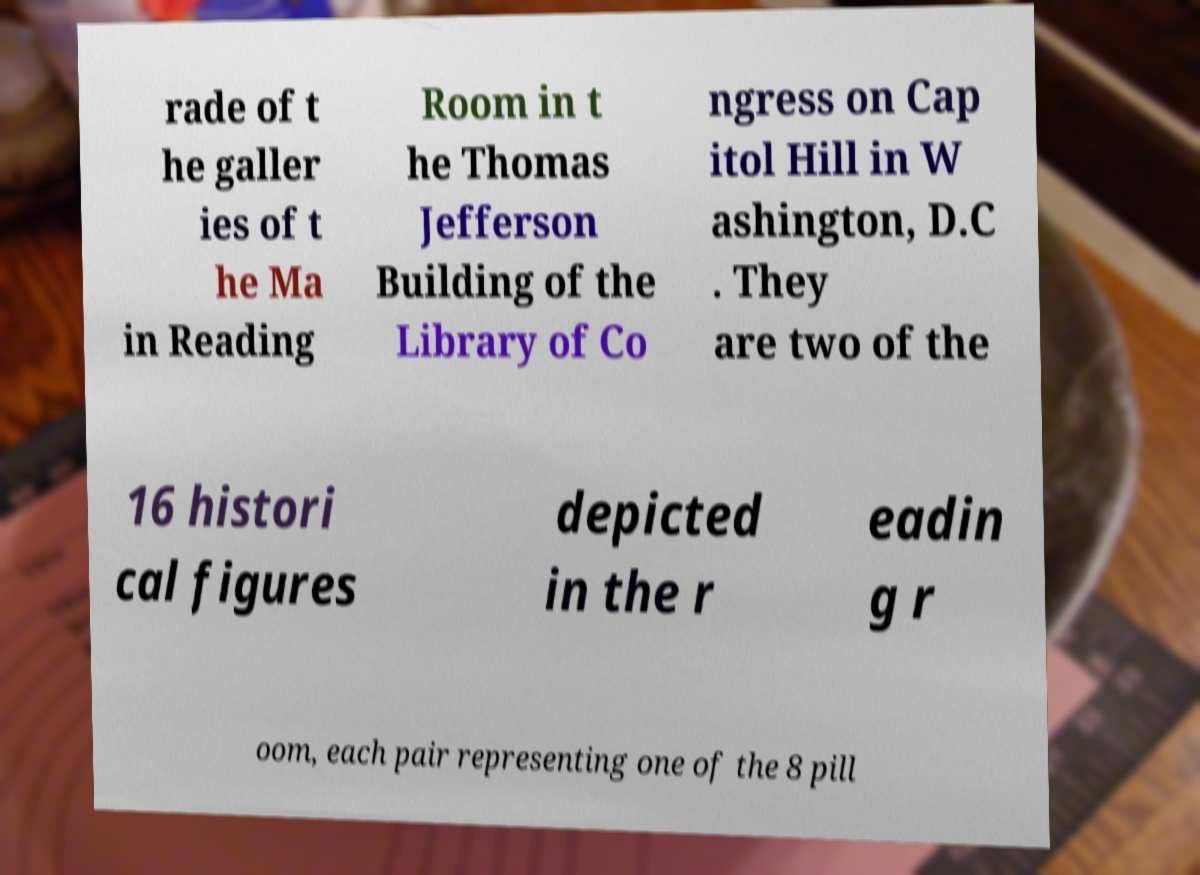What messages or text are displayed in this image? I need them in a readable, typed format. rade of t he galler ies of t he Ma in Reading Room in t he Thomas Jefferson Building of the Library of Co ngress on Cap itol Hill in W ashington, D.C . They are two of the 16 histori cal figures depicted in the r eadin g r oom, each pair representing one of the 8 pill 